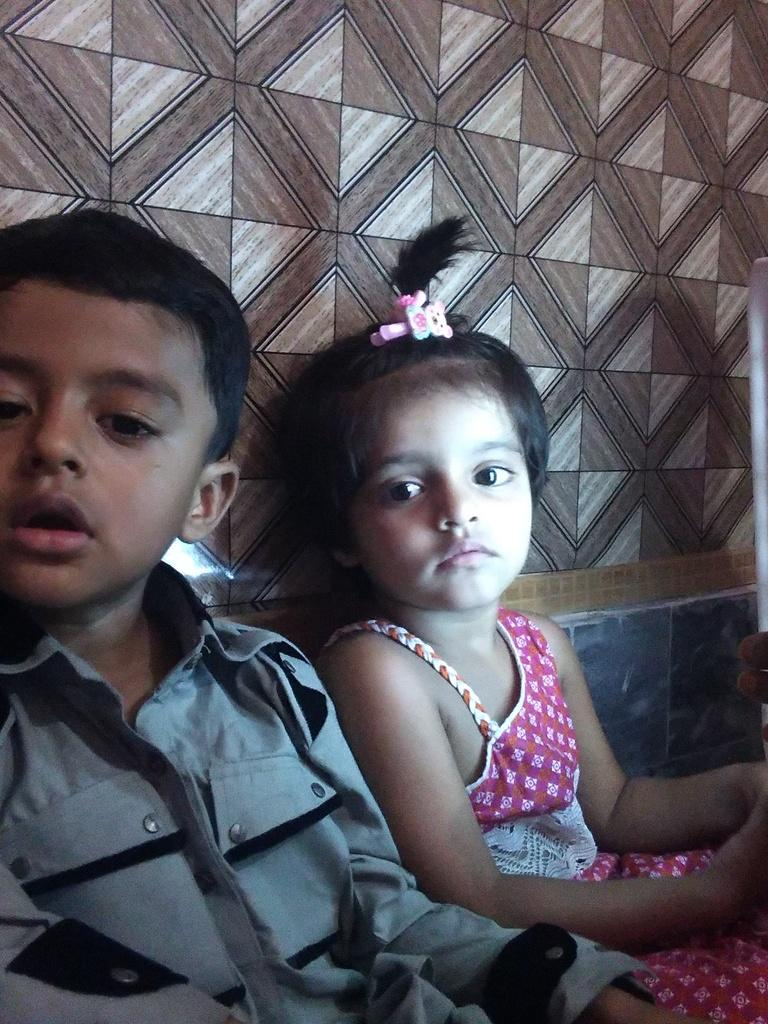How many children are present in the image? There are two kids in the image. What are the kids doing in the image? The kids are sitting near a wall. What type of stitch is being used to sew the deer's box in the image? There is no stitch, deer, or box present in the image. 